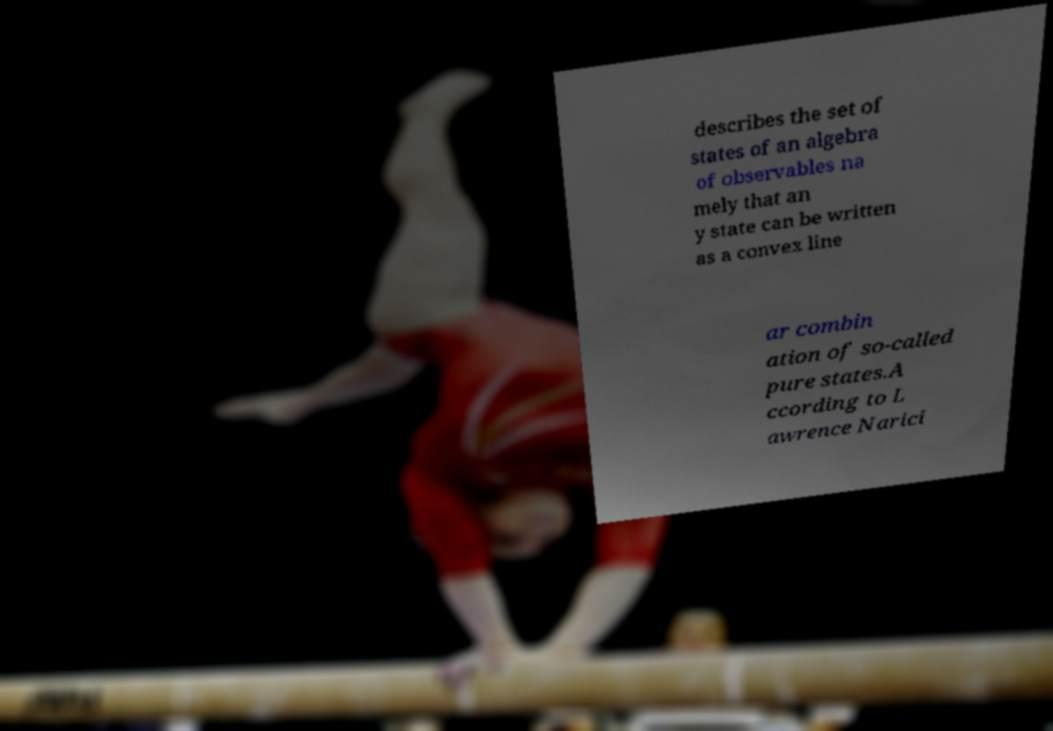Can you accurately transcribe the text from the provided image for me? describes the set of states of an algebra of observables na mely that an y state can be written as a convex line ar combin ation of so-called pure states.A ccording to L awrence Narici 